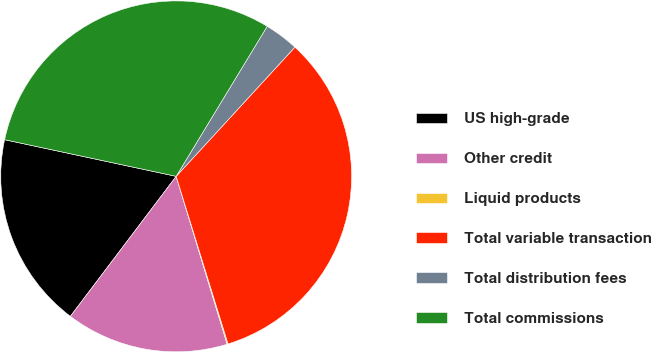Convert chart to OTSL. <chart><loc_0><loc_0><loc_500><loc_500><pie_chart><fcel>US high-grade<fcel>Other credit<fcel>Liquid products<fcel>Total variable transaction<fcel>Total distribution fees<fcel>Total commissions<nl><fcel>18.05%<fcel>14.99%<fcel>0.09%<fcel>33.39%<fcel>3.15%<fcel>30.33%<nl></chart> 